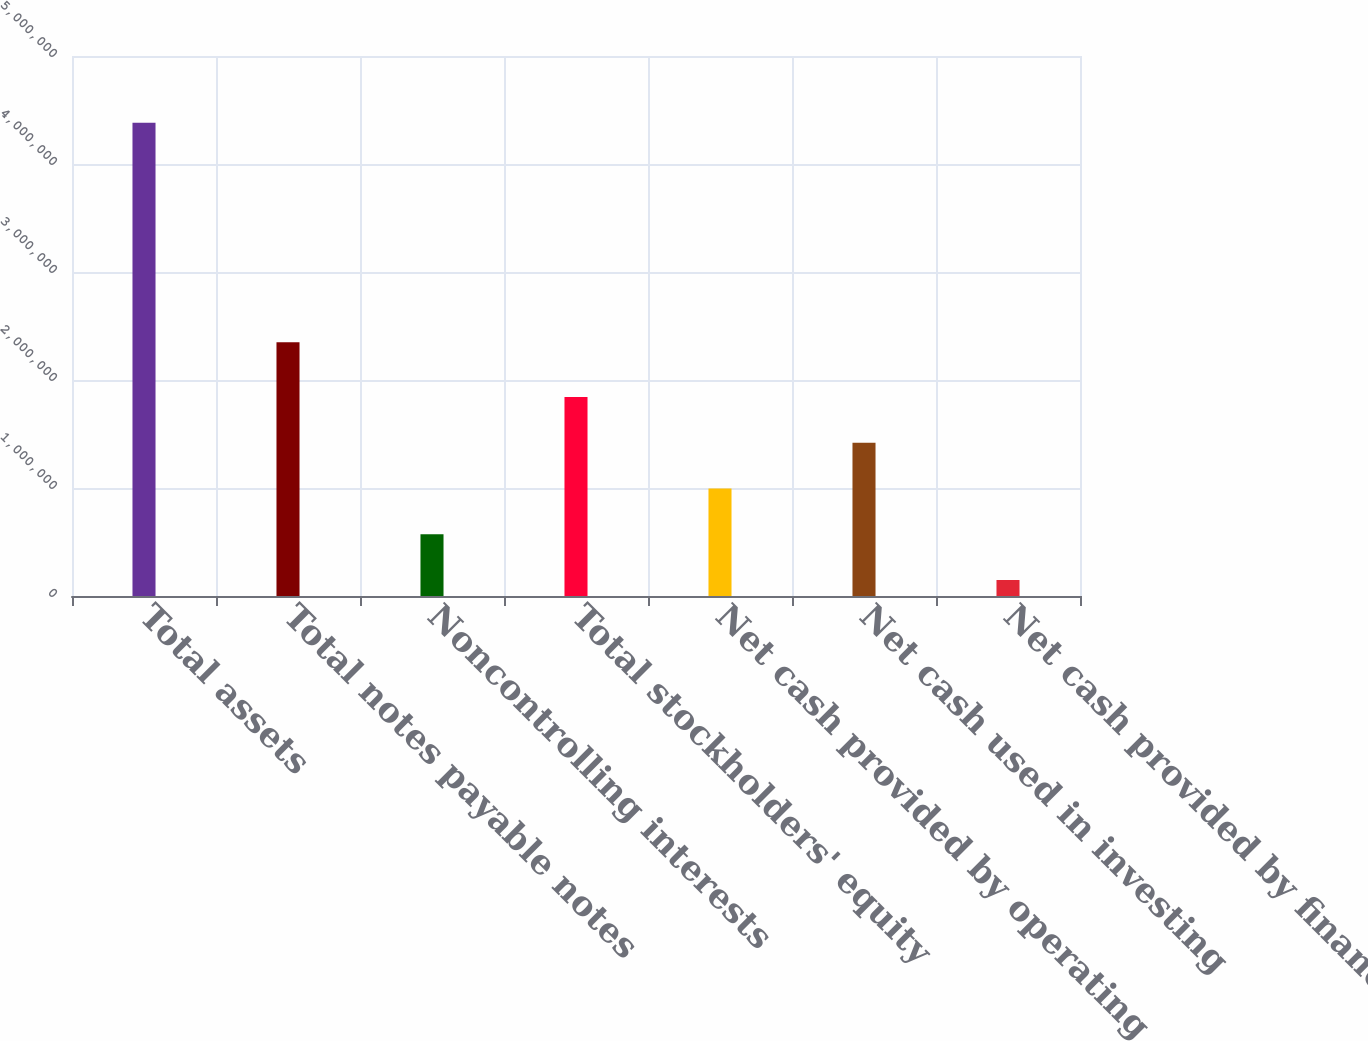Convert chart to OTSL. <chart><loc_0><loc_0><loc_500><loc_500><bar_chart><fcel>Total assets<fcel>Total notes payable notes<fcel>Noncontrolling interests<fcel>Total stockholders' equity<fcel>Net cash provided by operating<fcel>Net cash used in investing<fcel>Net cash provided by financing<nl><fcel>4.38199e+06<fcel>2.34976e+06<fcel>571675<fcel>1.84178e+06<fcel>995043<fcel>1.41841e+06<fcel>148307<nl></chart> 